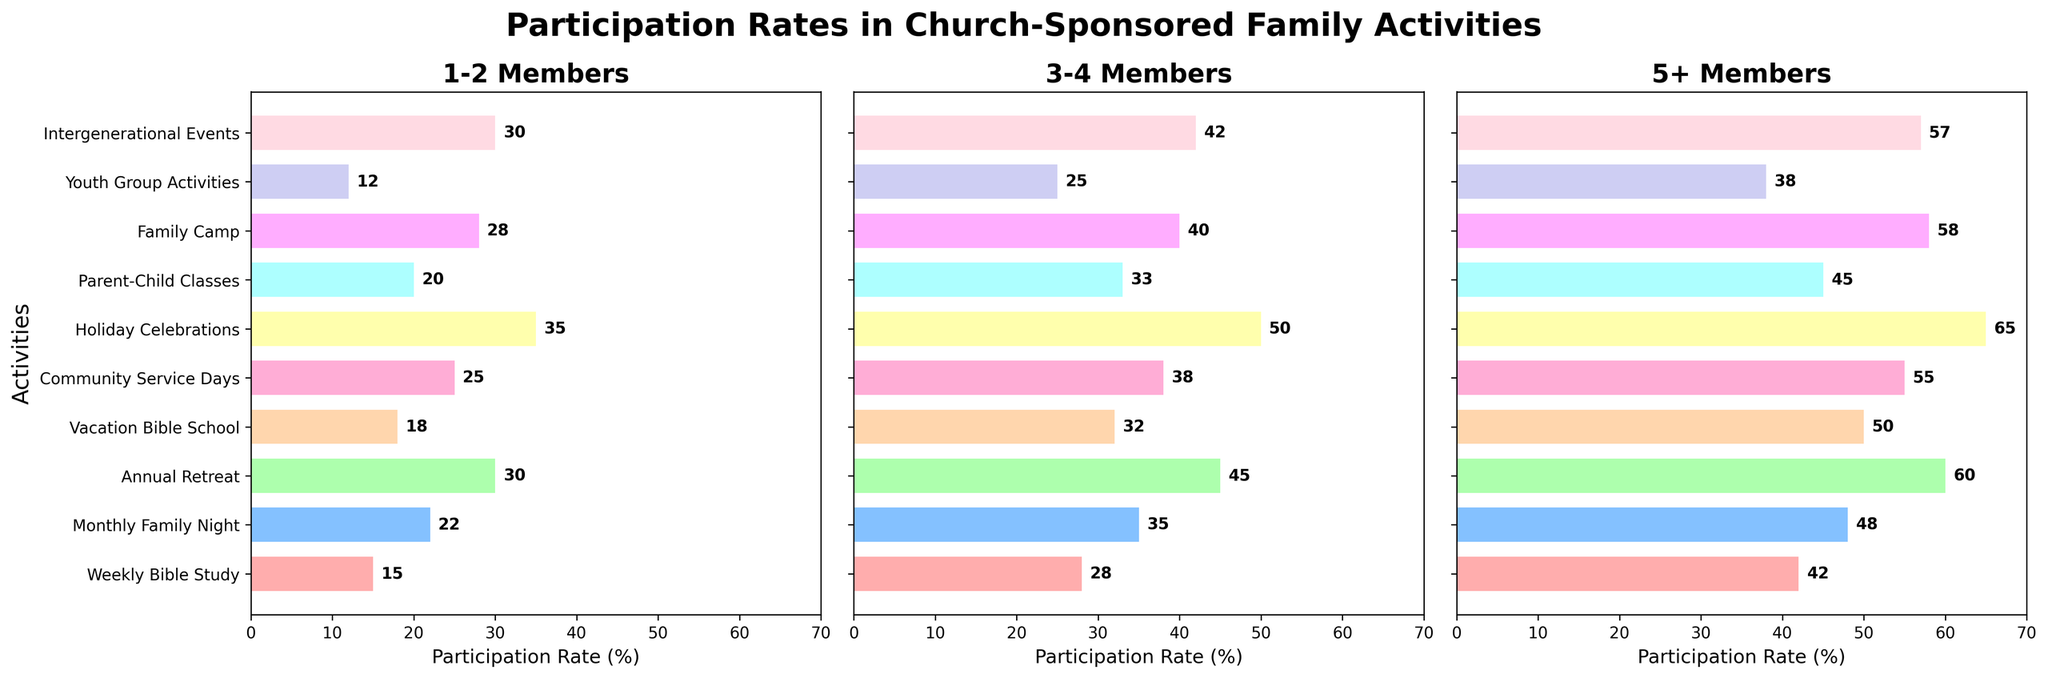What is the participation rate for Annual Retreat in families with 1-2 members? Look at the bar for Annual Retreat under the '1-2 Members' category. The label at the end of the bar indicates the percentage.
Answer: 30% Which family size has the highest participation rate in Monthly Family Night? Compare the bar lengths for Monthly Family Night among all three family sizes. The longest bar indicates the highest rate.
Answer: 5+ Members What is the difference in participation rates between Weekly Bible Study and Parent-Child Classes for families with 3-4 members? Find the bar lengths for Weekly Bible Study and Parent-Child Classes under the '3-4 Members' category and subtract the smaller value from the larger one (28 - 33).
Answer: 5% Which activity has the highest overall participation rate for families with 5+ members? Among all activities, find the bar with the greatest length under the '5+ Members' category.
Answer: Holiday Celebrations What is the average participation rate for Vacation Bible School and Community Service Days across all family sizes? Find the rates for Vacation Bible School and Community Service Days for each family size, sum them up and divide by the total number of rates ((18 + 32 + 50) + (25 + 38 + 55)) / 6.
Answer: 36.33% By how much does the participation rate in Family Camp for families with 3-4 members exceed that for Weekly Bible Study in the same size? Subtract the participation rate for Weekly Bible Study from that for Family Camp under the '3-4 Members' category (40 - 28).
Answer: 12% Compare the participation rates between Community Service Days and Intergenerational Events for families with 1-2 members. Which one is higher and by what percentage? Find the participation rates for both activities under '1-2 Members', compare them, and subtract the smaller value from the larger one (30 - 25).
Answer: Intergenerational Events by 5% What is the sum of participation rates for Youth Group Activities across all family sizes? Add the participation rates for Youth Group Activities for each family size (12 + 25 + 38).
Answer: 75% Which activity shows the most significant increase in participation rate from families with 1-2 members to families with 5+ members? For each activity, subtract the rate for families with 1-2 members from the rate for families with 5+ members, and find the largest result ((42-15), (48-22), (60-30), etc.).
Answer: Vacation Bible School Are the participation rates in Parent-Child Classes greater than or equal to those in Youth Group Activities for all family sizes? Compare the bars for Parent-Child Classes with those for Youth Group Activities in each family size category, ensuring that for 1-2 members (20 vs 12), for 3-4 members (33 vs 25), and for 5+ members (45 vs 38) are always greater.
Answer: Yes 